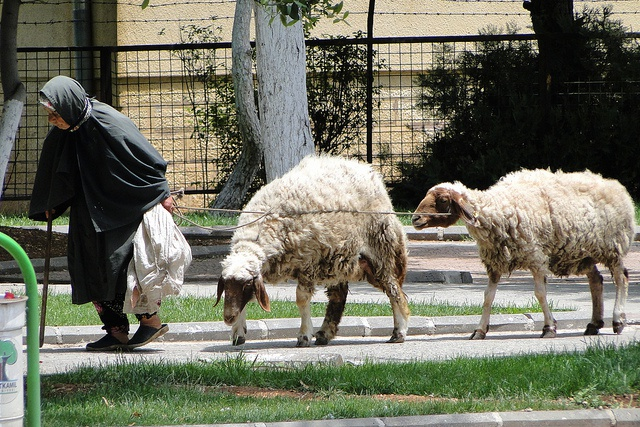Describe the objects in this image and their specific colors. I can see sheep in black, ivory, darkgray, and gray tones and people in black, darkgray, gray, and white tones in this image. 